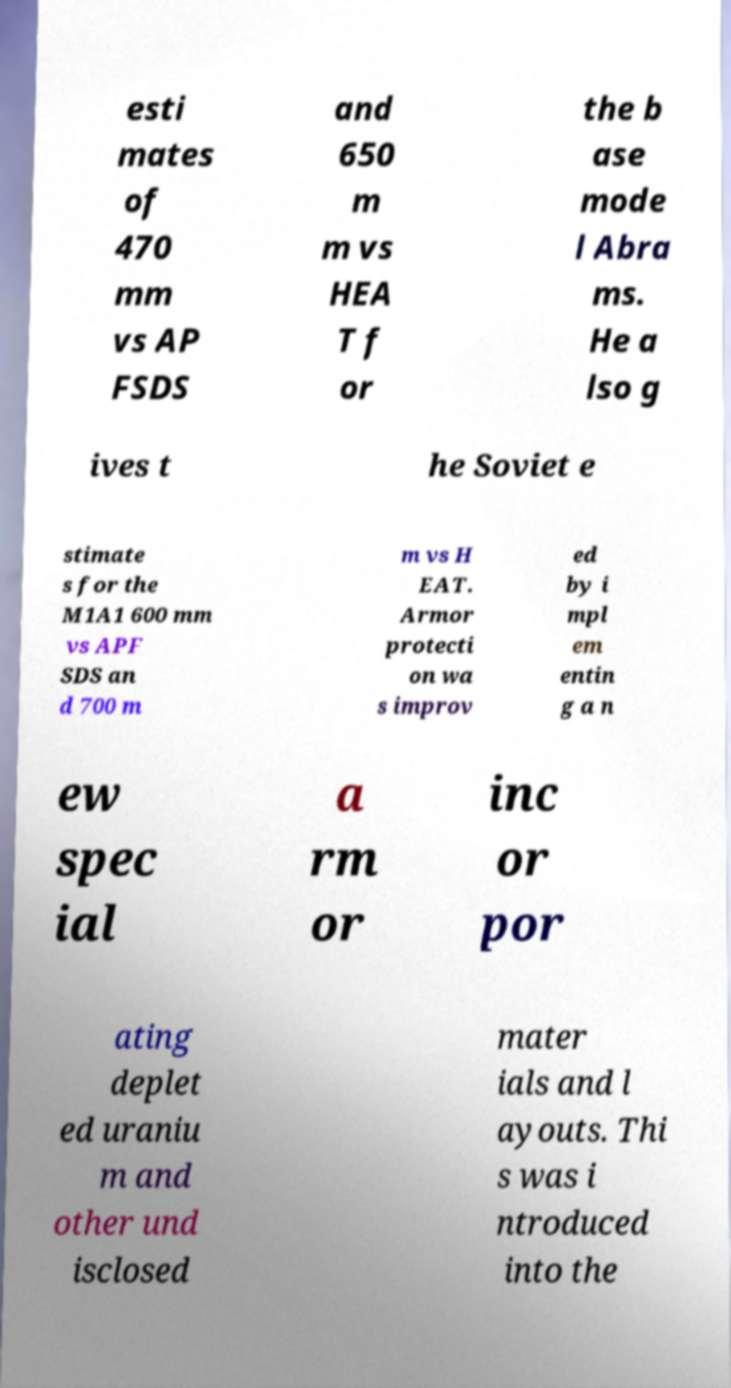Can you accurately transcribe the text from the provided image for me? esti mates of 470 mm vs AP FSDS and 650 m m vs HEA T f or the b ase mode l Abra ms. He a lso g ives t he Soviet e stimate s for the M1A1 600 mm vs APF SDS an d 700 m m vs H EAT. Armor protecti on wa s improv ed by i mpl em entin g a n ew spec ial a rm or inc or por ating deplet ed uraniu m and other und isclosed mater ials and l ayouts. Thi s was i ntroduced into the 